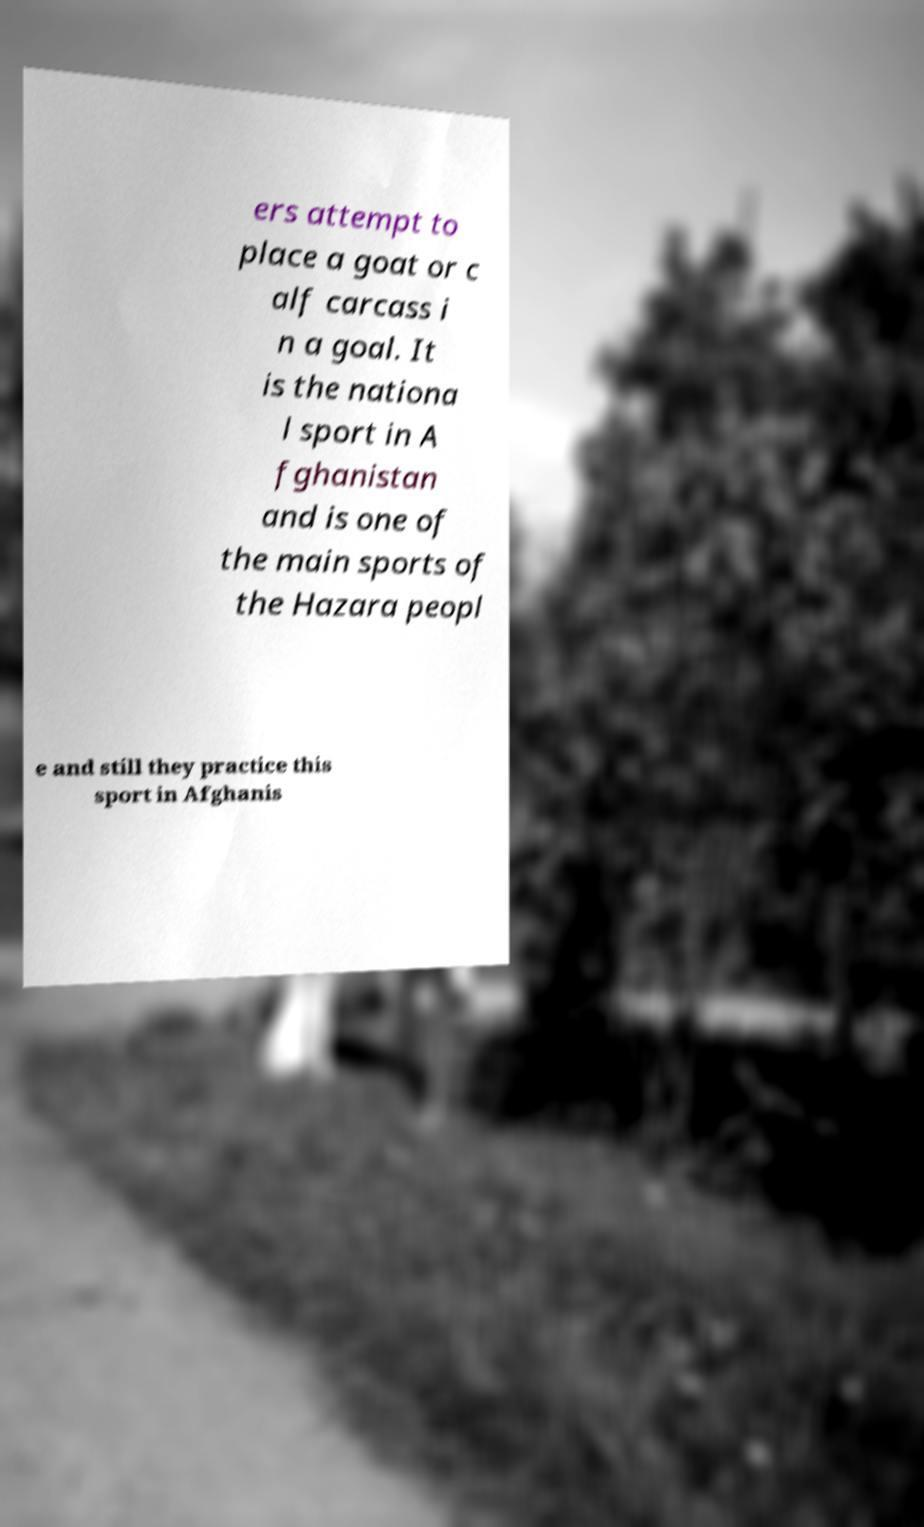What messages or text are displayed in this image? I need them in a readable, typed format. ers attempt to place a goat or c alf carcass i n a goal. It is the nationa l sport in A fghanistan and is one of the main sports of the Hazara peopl e and still they practice this sport in Afghanis 